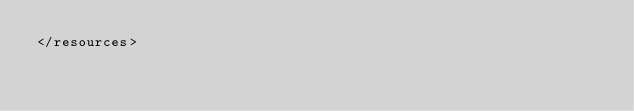Convert code to text. <code><loc_0><loc_0><loc_500><loc_500><_XML_></resources>
</code> 